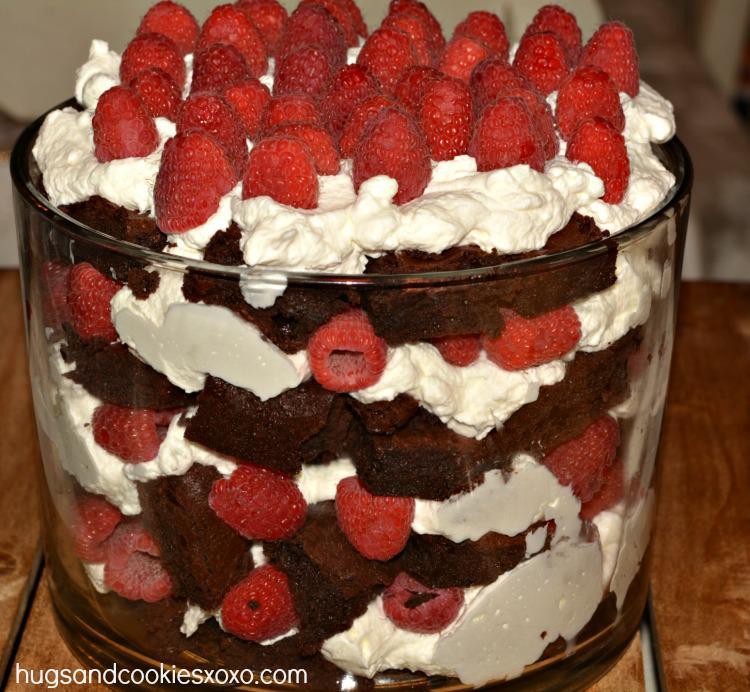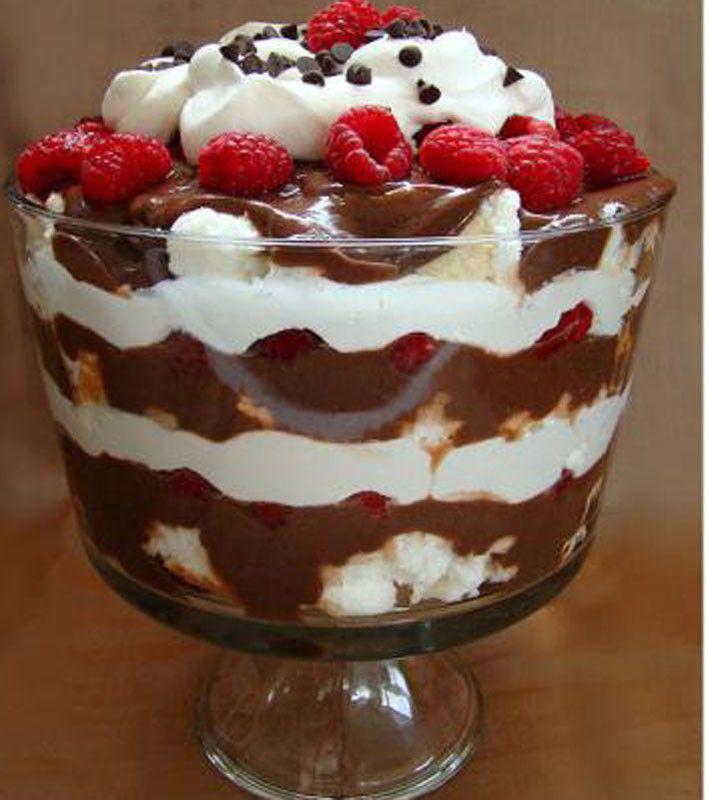The first image is the image on the left, the second image is the image on the right. Assess this claim about the two images: "At least one dessert is topped with brown shavings and served in a footed glass.". Correct or not? Answer yes or no. No. The first image is the image on the left, the second image is the image on the right. Assess this claim about the two images: "There are two layered desserts in visibly stemmed cups.". Correct or not? Answer yes or no. No. 